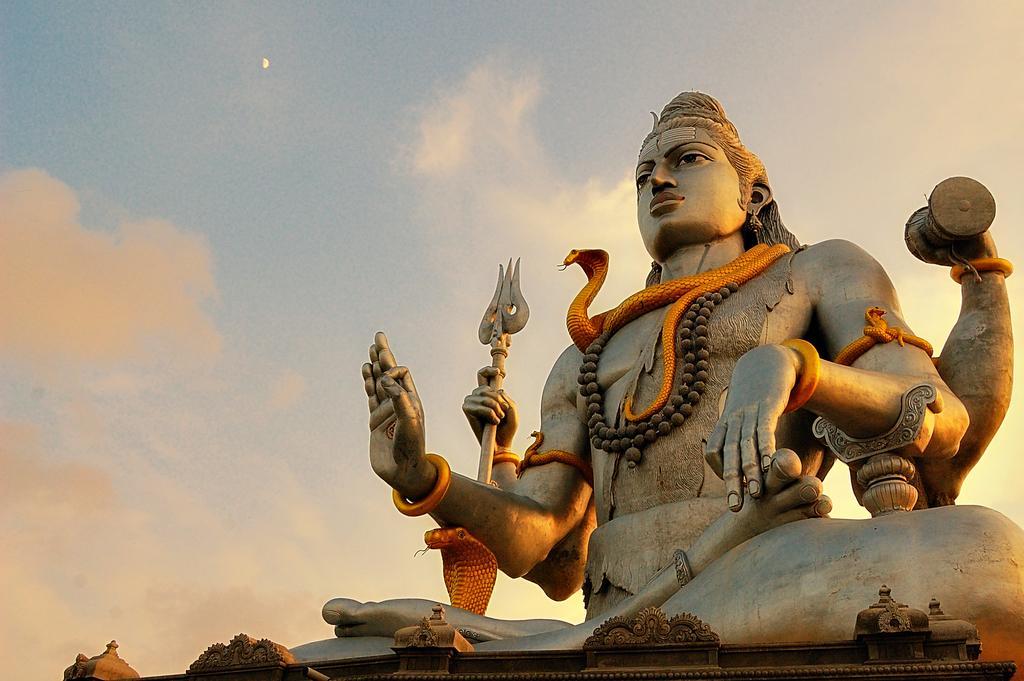Describe this image in one or two sentences. In the middle of the image we can see a statue. At the top of the image we can see some clouds and moon in the sky. 